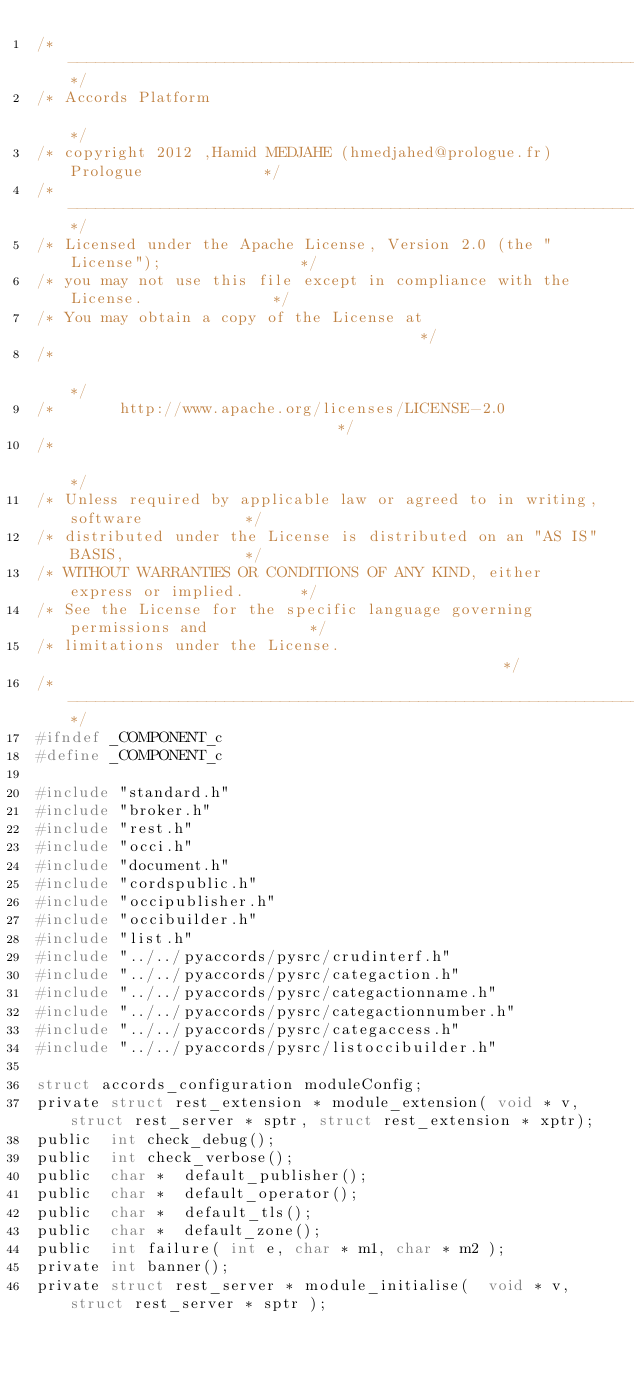Convert code to text. <code><loc_0><loc_0><loc_500><loc_500><_C_>/*-------------------------------------------------------------------------------*/
/* Accords Platform                                                              */
/* copyright 2012 ,Hamid MEDJAHE (hmedjahed@prologue.fr)    Prologue             */
/*-------------------------------------------------------------------------------*/
/* Licensed under the Apache License, Version 2.0 (the "License");               */
/* you may not use this file except in compliance with the License.              */
/* You may obtain a copy of the License at                                       */
/*                                                                               */
/*       http://www.apache.org/licenses/LICENSE-2.0                              */
/*                                                                               */
/* Unless required by applicable law or agreed to in writing, software           */
/* distributed under the License is distributed on an "AS IS" BASIS,             */
/* WITHOUT WARRANTIES OR CONDITIONS OF ANY KIND, either express or implied.      */
/* See the License for the specific language governing permissions and           */
/* limitations under the License.                                                */
/*-------------------------------------------------------------------------------*/
#ifndef	_COMPONENT_c
#define	_COMPONENT_c
 
#include "standard.h"
#include "broker.h"
#include "rest.h"
#include "occi.h"
#include "document.h"
#include "cordspublic.h"
#include "occipublisher.h"
#include "occibuilder.h"
#include "list.h"
#include "../../pyaccords/pysrc/crudinterf.h"
#include "../../pyaccords/pysrc/categaction.h"
#include "../../pyaccords/pysrc/categactionname.h"
#include "../../pyaccords/pysrc/categactionnumber.h"
#include "../../pyaccords/pysrc/categaccess.h"
#include "../../pyaccords/pysrc/listoccibuilder.h"

struct accords_configuration moduleConfig;
private	struct rest_extension * module_extension( void * v,struct rest_server * sptr, struct rest_extension * xptr);
public	int	check_debug();
public	int	check_verbose();	
public	char *	default_publisher();	
public	char *	default_operator();	
public	char *	default_tls();	
public	char *	default_zone();
public	int	failure( int e, char * m1, char * m2 );
private	int banner();
private	struct rest_server * module_initialise(  void * v,struct rest_server * sptr );
</code> 